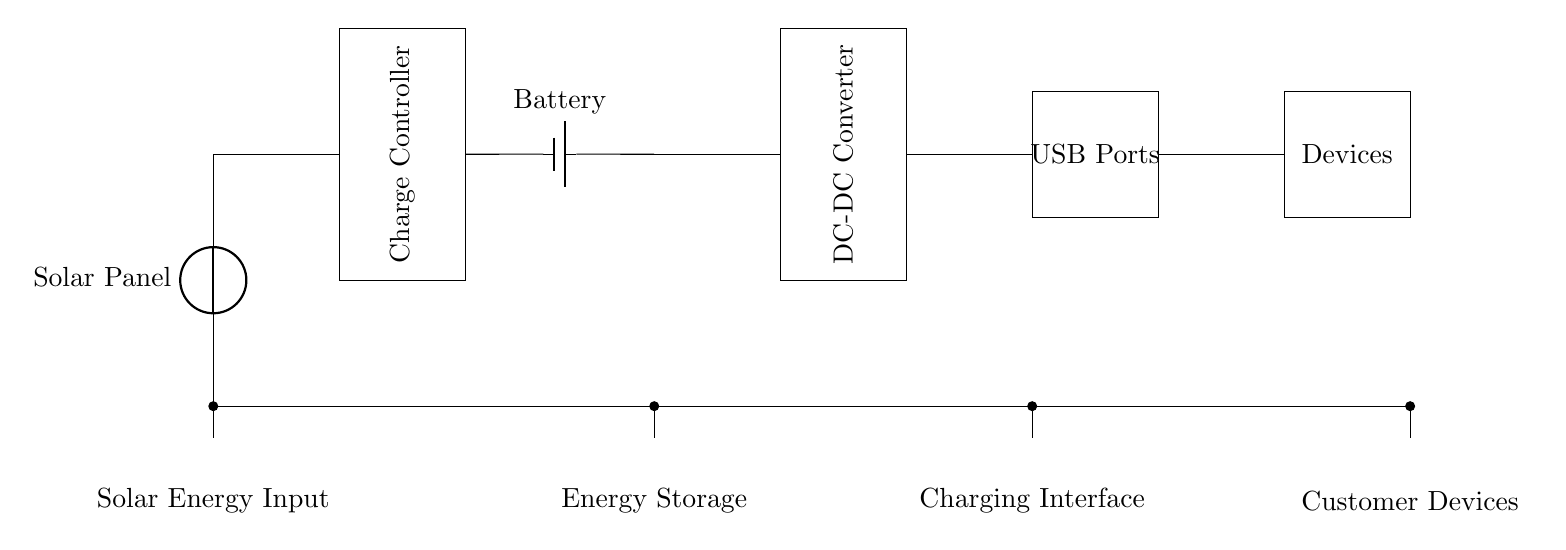What is the first component in the circuit? The first component is the Solar Panel, depicted at the top of the diagram as the source of solar energy for charging.
Answer: Solar Panel What is the purpose of the charge controller? The charge controller regulates the voltage and current coming from the solar panel before it reaches the battery, ensuring safe charging and preventing overcharging.
Answer: Regulates charging How many USB ports are there? There is one rectangle labeled "USB Ports" in the circuit, indicating the presence of multiple charging interfaces typically represented by this label.
Answer: One What is the role of the battery in this circuit? The battery stores the energy collected by the solar panel and delivers it through the charge controller to the USB ports for charging devices.
Answer: Energy storage Which component directly connects to the devices? The USB Ports connect directly to the Devices, allowing charging to occur at this interface without any additional components in between.
Answer: USB Ports What is the energy flow sequence from the solar panel to the devices? Energy flows from the Solar Panel to the Charge Controller, then to the Battery, and finally to the USB Ports where it charges the Customer Devices.
Answer: Solar Panel → Charge Controller → Battery → USB Ports What type of energy source does this circuit utilize? The circuit utilizes solar energy as the primary energy source, harnessed by the solar panel to facilitate eco-friendly charging.
Answer: Solar energy 